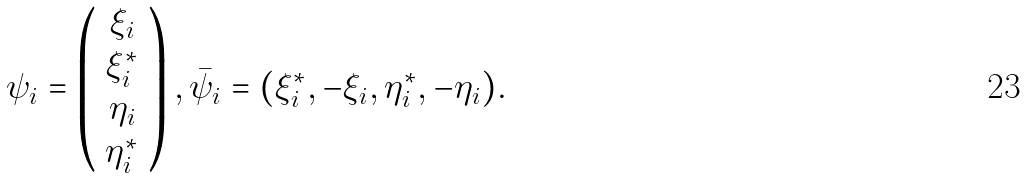<formula> <loc_0><loc_0><loc_500><loc_500>\psi _ { i } = \left ( \begin{array} { c } \xi _ { i } \\ \xi _ { i } ^ { * } \\ \eta _ { i } \\ \eta _ { i } ^ { * } \end{array} \right ) , \bar { \psi } _ { i } = ( \xi _ { i } ^ { * } , - \xi _ { i } , \eta _ { i } ^ { * } , - \eta _ { i } ) .</formula> 